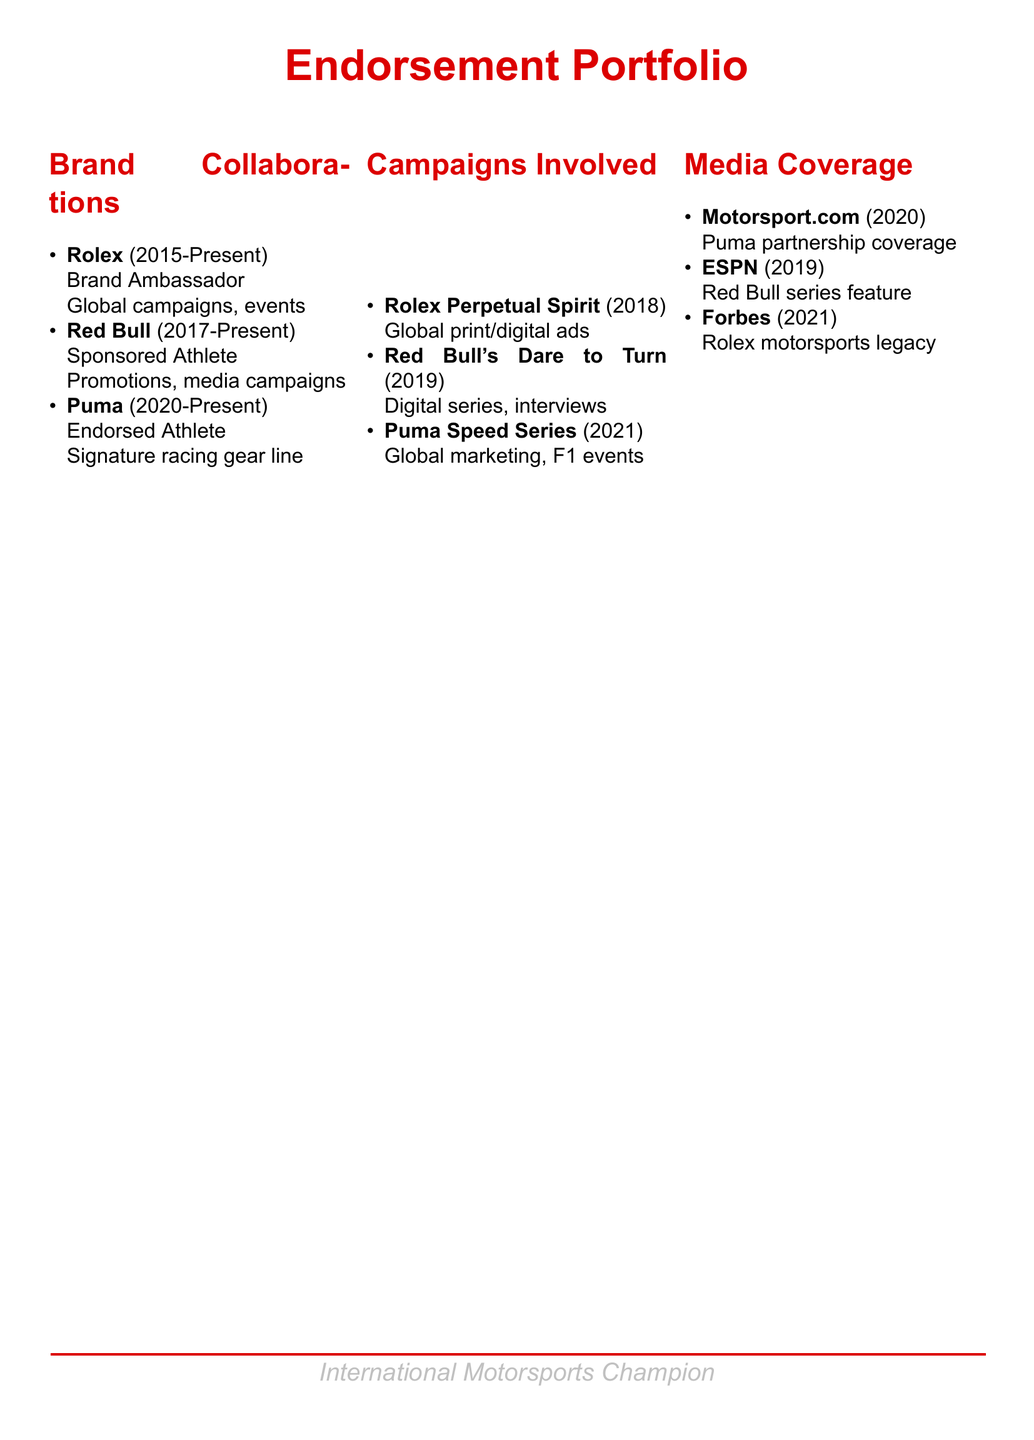What is the role of Rolex in your endorsement portfolio? Rolex is mentioned as a Brand Ambassador, signifying a promotional relationship where the champion represents the brand.
Answer: Brand Ambassador In what year did the partnership with Puma begin? The document specifies that the collaboration with Puma started in the year 2020.
Answer: 2020 Which campaign is associated with Red Bull? The document lists "Red Bull's Dare to Turn" as a campaign, indicating collaboration and promotional efforts with that brand.
Answer: Red Bull's Dare to Turn Who covered the Puma partnership in their media? The document indicates that Motorsport.com provided coverage regarding the Puma partnership.
Answer: Motorsport.com What type of media coverage did ESPN provide in 2019? The mention of ESPN communicates that they featured a series related to Red Bull in 2019, highlighting involvement with the champion.
Answer: Red Bull series feature How long has the collaboration with Rolex lasted as of the document date? The document indicates that the partnership with Rolex started in 2015 and is ongoing as of the current date, thus lasting several years.
Answer: 8 years Which campaign involved global marketing at F1 events? The document notes "Puma Speed Series" as the campaign that involved global marketing efforts at Formula 1 events.
Answer: Puma Speed Series What color theme is used for the document title? The title of the document is in a red color, specifically labeled as racing red within the document's code.
Answer: Racing red 